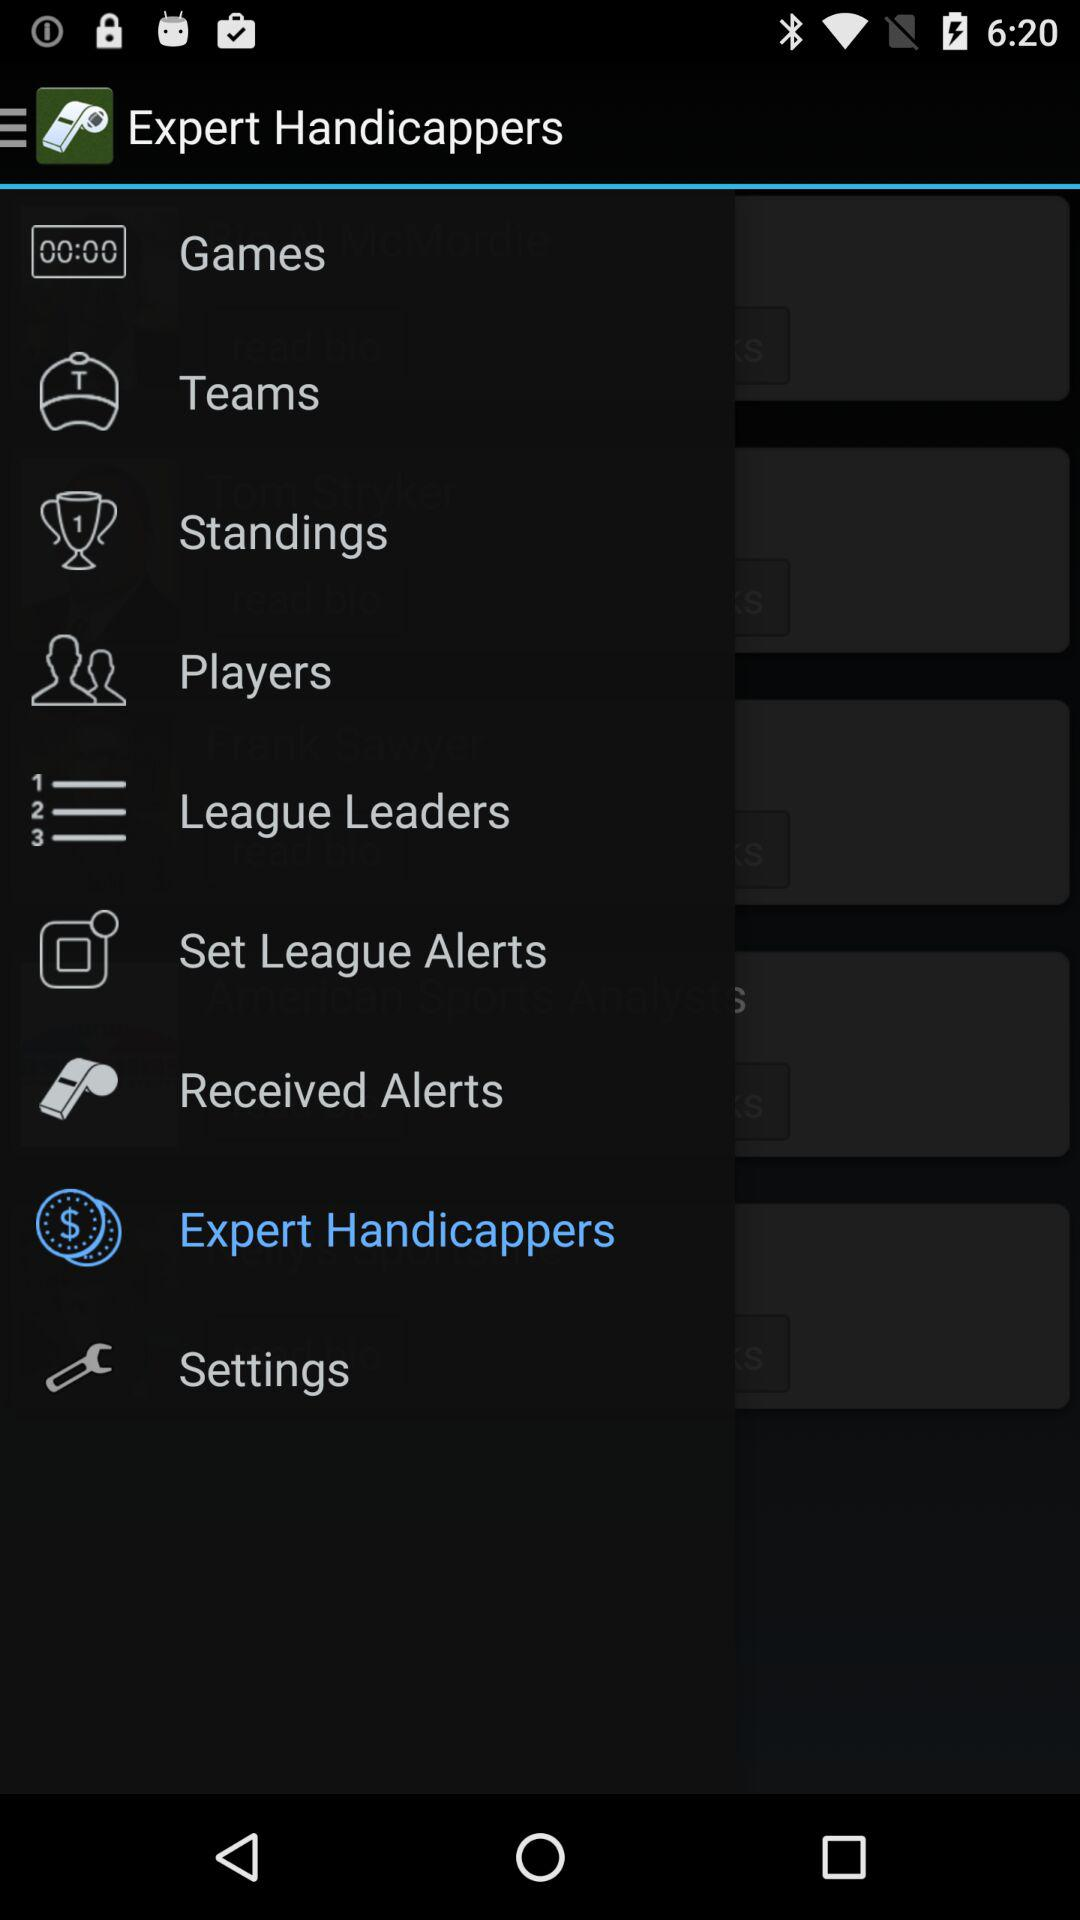Which item has been selected? The item "Expert Handicappers" has been selected. 